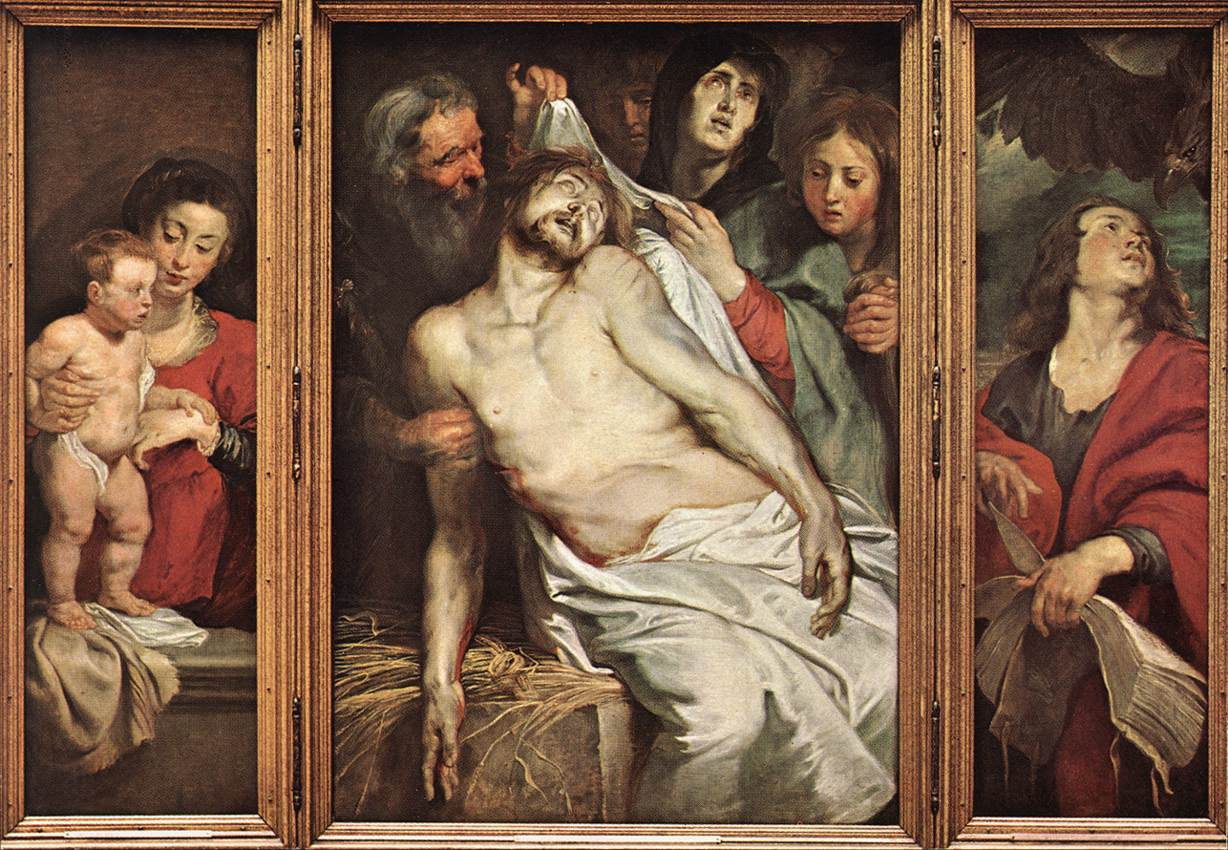Who are the figures represented in this painting, and what is their significance? This painting likely depicts the biblical scene of the Entombment of Christ. The central figure is Jesus, characterized by the stigmata and white shroud. Surrounding him are key figures from Christian texts: Mary, Jesus' mother, holding the infant representing innocence and the continuation of faith; John the Apostle, often shown in red, who looks skyward, possibly seeking divine understanding or strength. The others may represent additional apostles and Mary Magdalene, each reflecting a personal connection and mourning for the loss of Christ. 